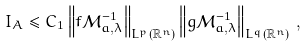Convert formula to latex. <formula><loc_0><loc_0><loc_500><loc_500>I _ { A } \leq C _ { 1 } \left \| f \mathcal { M } ^ { - 1 } _ { a , \lambda } \right \| _ { L ^ { p } ( \mathbb { R } ^ { n } ) } \left \| g \mathcal { M } ^ { - 1 } _ { a , \lambda } \right \| _ { L ^ { q } ( \mathbb { R } ^ { n } ) } \, ,</formula> 